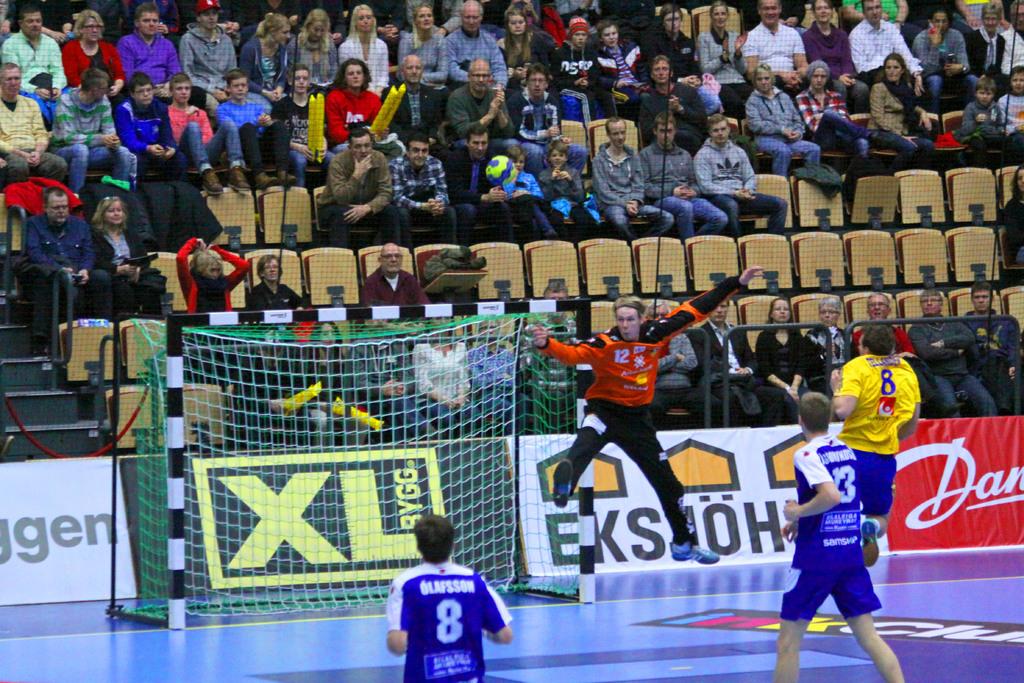Volley ball is playing?
Ensure brevity in your answer.  Answering does not require reading text in the image. What is written in yellow on the green sign?
Offer a very short reply. Xl. 